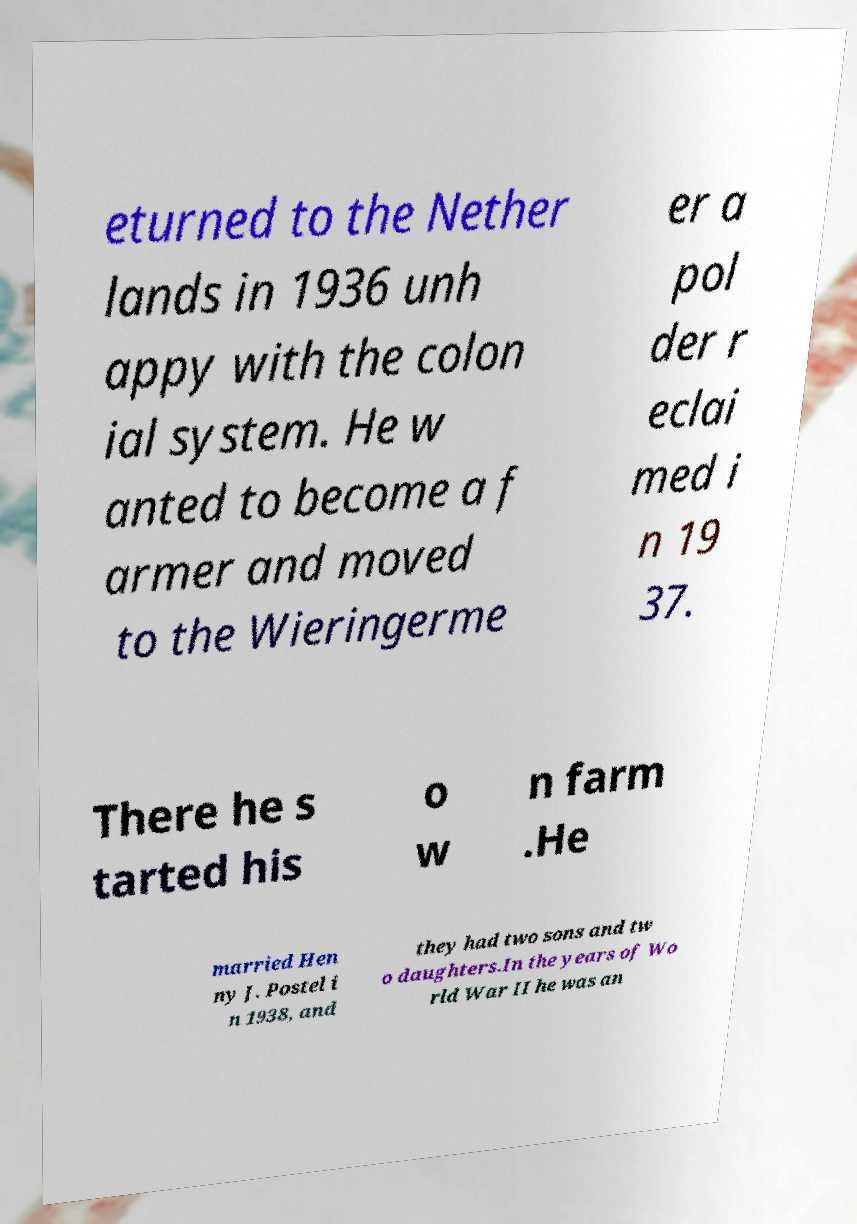I need the written content from this picture converted into text. Can you do that? eturned to the Nether lands in 1936 unh appy with the colon ial system. He w anted to become a f armer and moved to the Wieringerme er a pol der r eclai med i n 19 37. There he s tarted his o w n farm .He married Hen ny J. Postel i n 1938, and they had two sons and tw o daughters.In the years of Wo rld War II he was an 